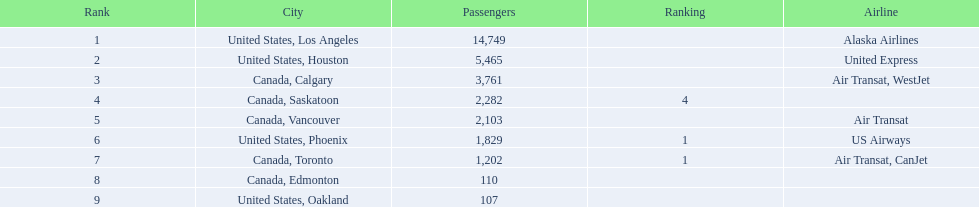Which airport experiences the lowest passenger traffic? 107. What airport has a count of 107 passengers? United States, Oakland. 